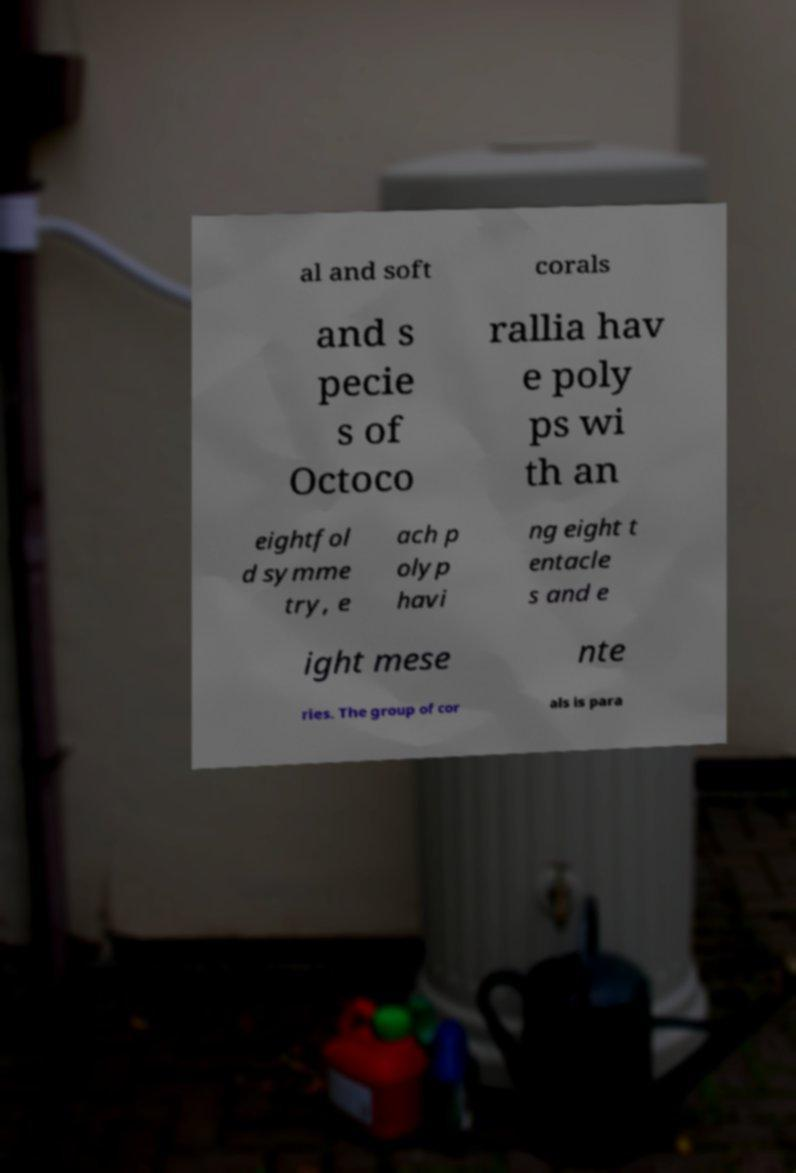Could you assist in decoding the text presented in this image and type it out clearly? al and soft corals and s pecie s of Octoco rallia hav e poly ps wi th an eightfol d symme try, e ach p olyp havi ng eight t entacle s and e ight mese nte ries. The group of cor als is para 